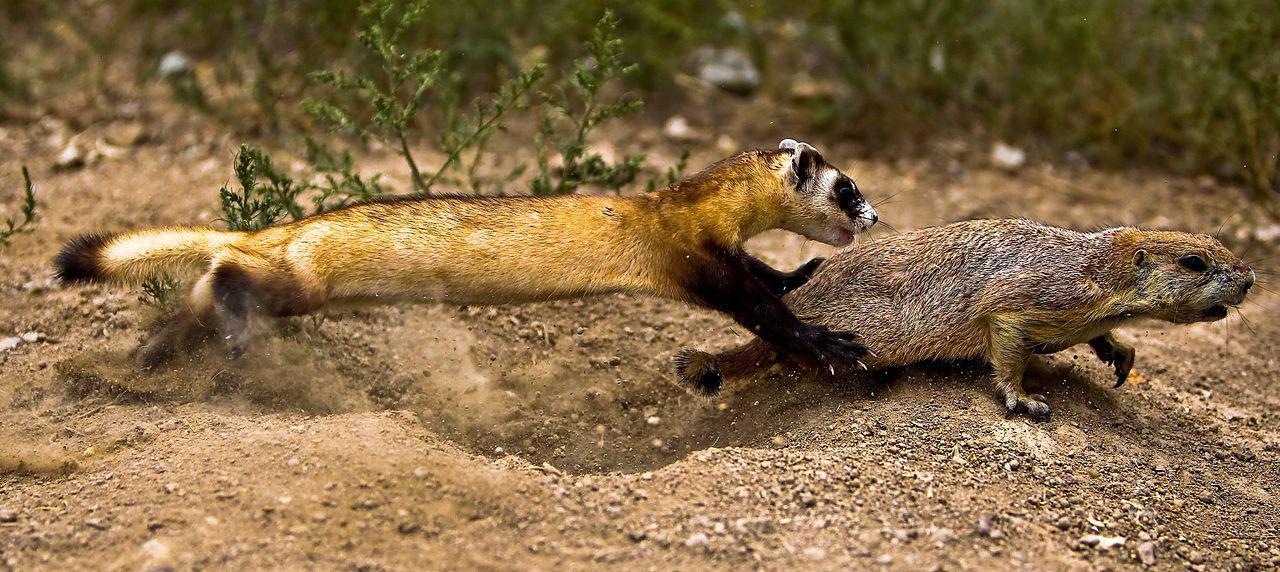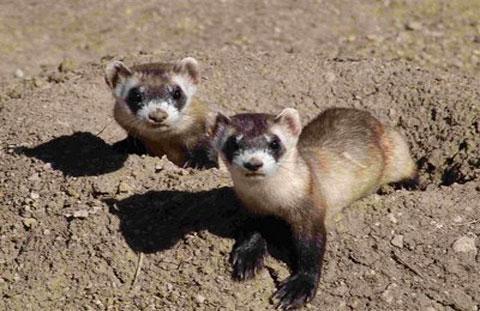The first image is the image on the left, the second image is the image on the right. Assess this claim about the two images: "Each image shows a single ferret, and each ferrret is standing on all fours and looking toward the camera.". Correct or not? Answer yes or no. No. 